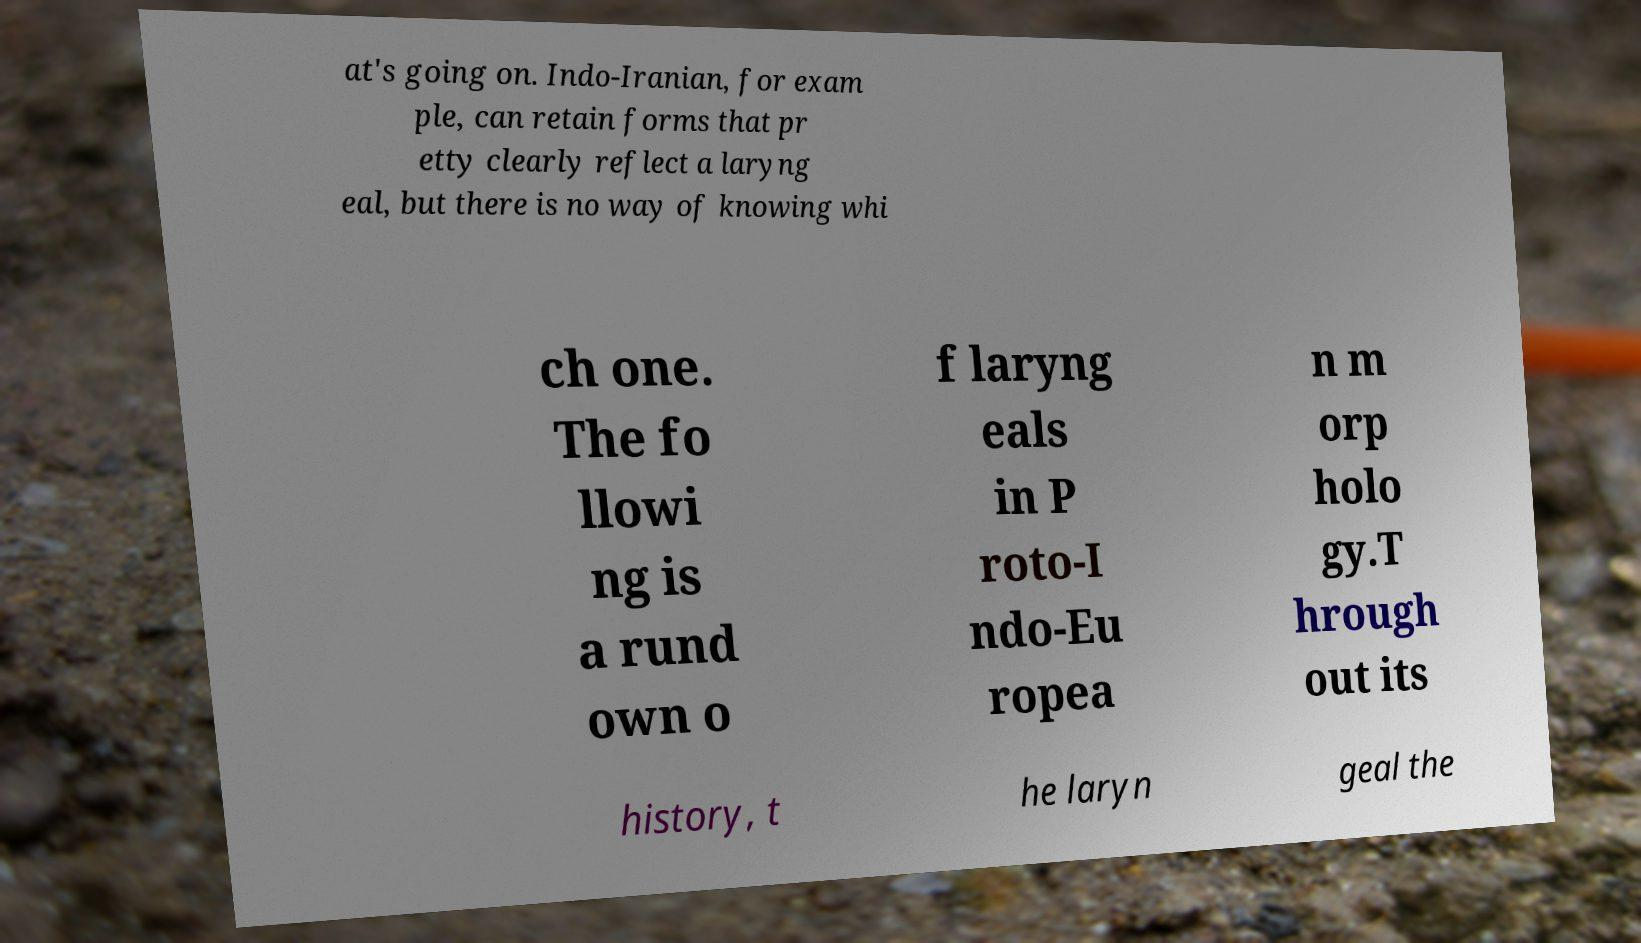Could you assist in decoding the text presented in this image and type it out clearly? at's going on. Indo-Iranian, for exam ple, can retain forms that pr etty clearly reflect a laryng eal, but there is no way of knowing whi ch one. The fo llowi ng is a rund own o f laryng eals in P roto-I ndo-Eu ropea n m orp holo gy.T hrough out its history, t he laryn geal the 